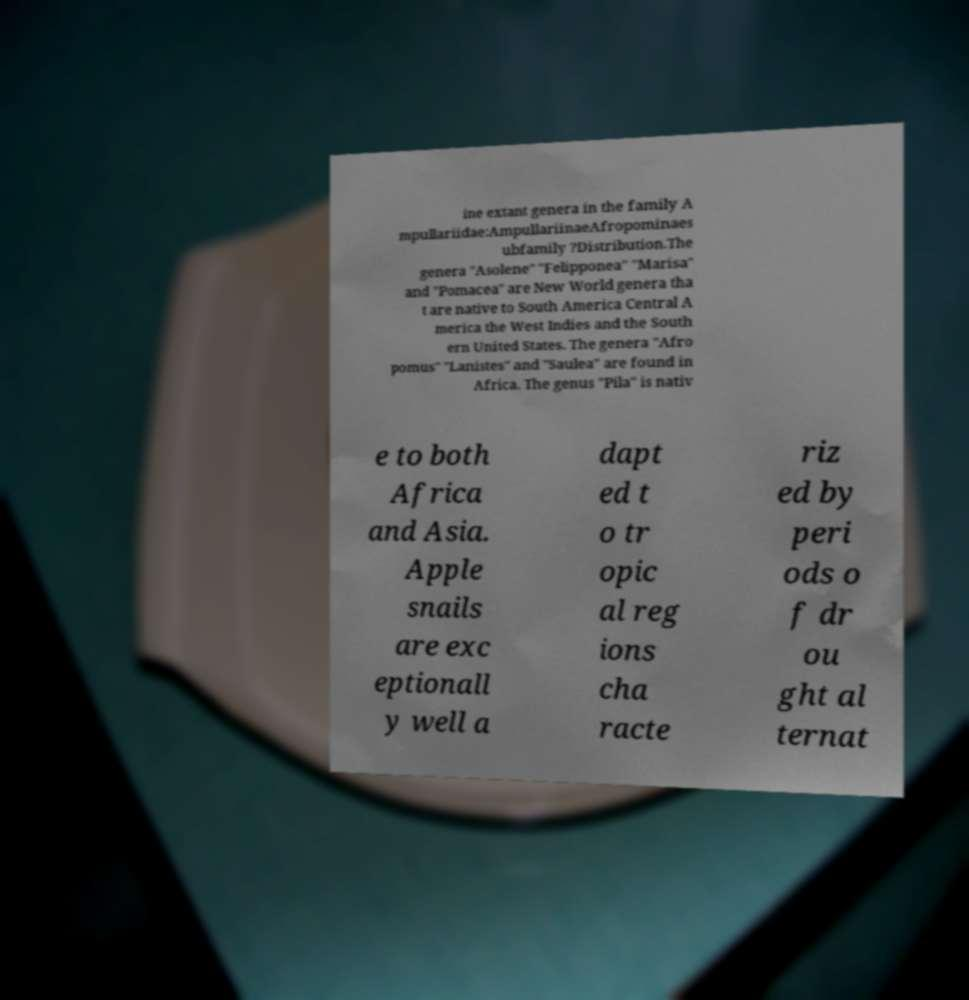For documentation purposes, I need the text within this image transcribed. Could you provide that? ine extant genera in the family A mpullariidae:AmpullariinaeAfropominaes ubfamily ?Distribution.The genera "Asolene" "Felipponea" "Marisa" and "Pomacea" are New World genera tha t are native to South America Central A merica the West Indies and the South ern United States. The genera "Afro pomus" "Lanistes" and "Saulea" are found in Africa. The genus "Pila" is nativ e to both Africa and Asia. Apple snails are exc eptionall y well a dapt ed t o tr opic al reg ions cha racte riz ed by peri ods o f dr ou ght al ternat 